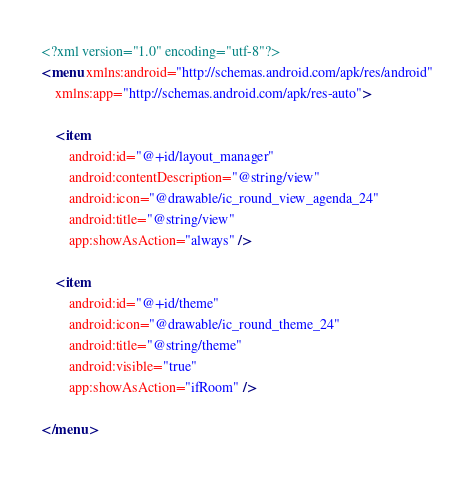<code> <loc_0><loc_0><loc_500><loc_500><_XML_><?xml version="1.0" encoding="utf-8"?>
<menu xmlns:android="http://schemas.android.com/apk/res/android"
    xmlns:app="http://schemas.android.com/apk/res-auto">

    <item
        android:id="@+id/layout_manager"
        android:contentDescription="@string/view"
        android:icon="@drawable/ic_round_view_agenda_24"
        android:title="@string/view"
        app:showAsAction="always" />

    <item
        android:id="@+id/theme"
        android:icon="@drawable/ic_round_theme_24"
        android:title="@string/theme"
        android:visible="true"
        app:showAsAction="ifRoom" />

</menu></code> 